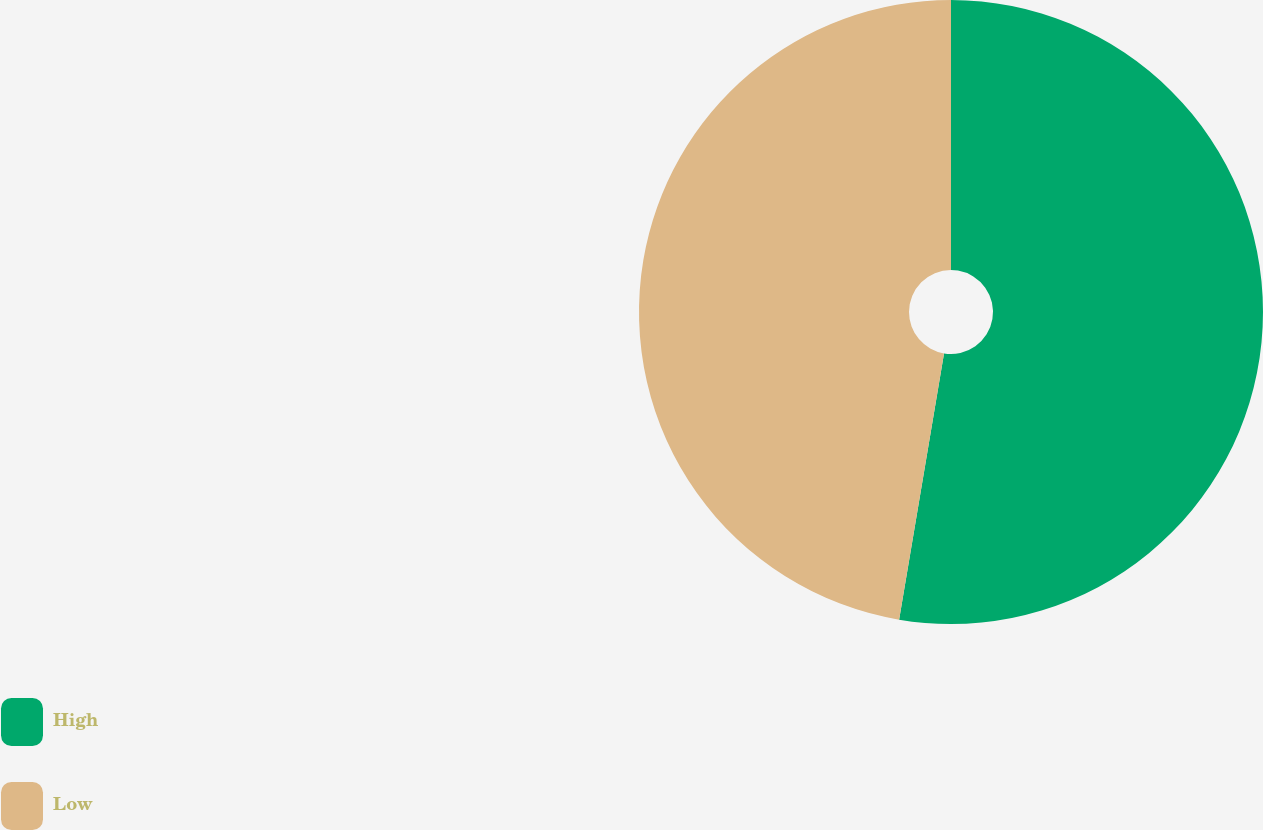<chart> <loc_0><loc_0><loc_500><loc_500><pie_chart><fcel>High<fcel>Low<nl><fcel>52.66%<fcel>47.34%<nl></chart> 